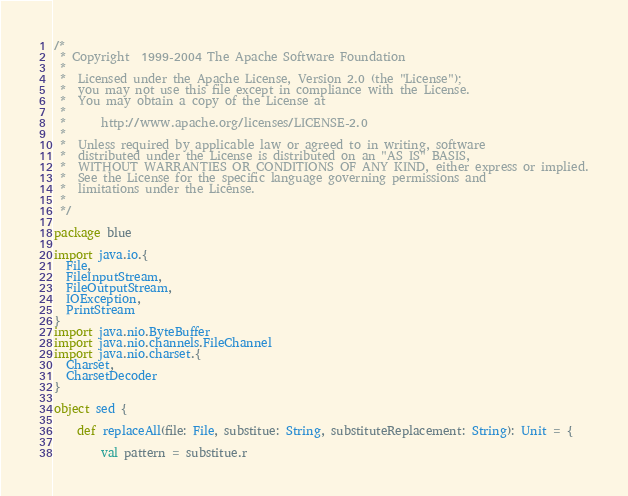Convert code to text. <code><loc_0><loc_0><loc_500><loc_500><_Scala_>/*
 * Copyright  1999-2004 The Apache Software Foundation
 *
 *  Licensed under the Apache License, Version 2.0 (the "License");
 *  you may not use this file except in compliance with the License.
 *  You may obtain a copy of the License at
 *
 *      http://www.apache.org/licenses/LICENSE-2.0
 *
 *  Unless required by applicable law or agreed to in writing, software
 *  distributed under the License is distributed on an "AS IS" BASIS,
 *  WITHOUT WARRANTIES OR CONDITIONS OF ANY KIND, either express or implied.
 *  See the License for the specific language governing permissions and
 *  limitations under the License.
 *
 */

package blue

import java.io.{
  File,
  FileInputStream,
  FileOutputStream,
  IOException,
  PrintStream
}
import java.nio.ByteBuffer
import java.nio.channels.FileChannel
import java.nio.charset.{
  Charset,
  CharsetDecoder
}

object sed {

    def replaceAll(file: File, substitue: String, substituteReplacement: String): Unit = {

        val pattern = substitue.r
</code> 